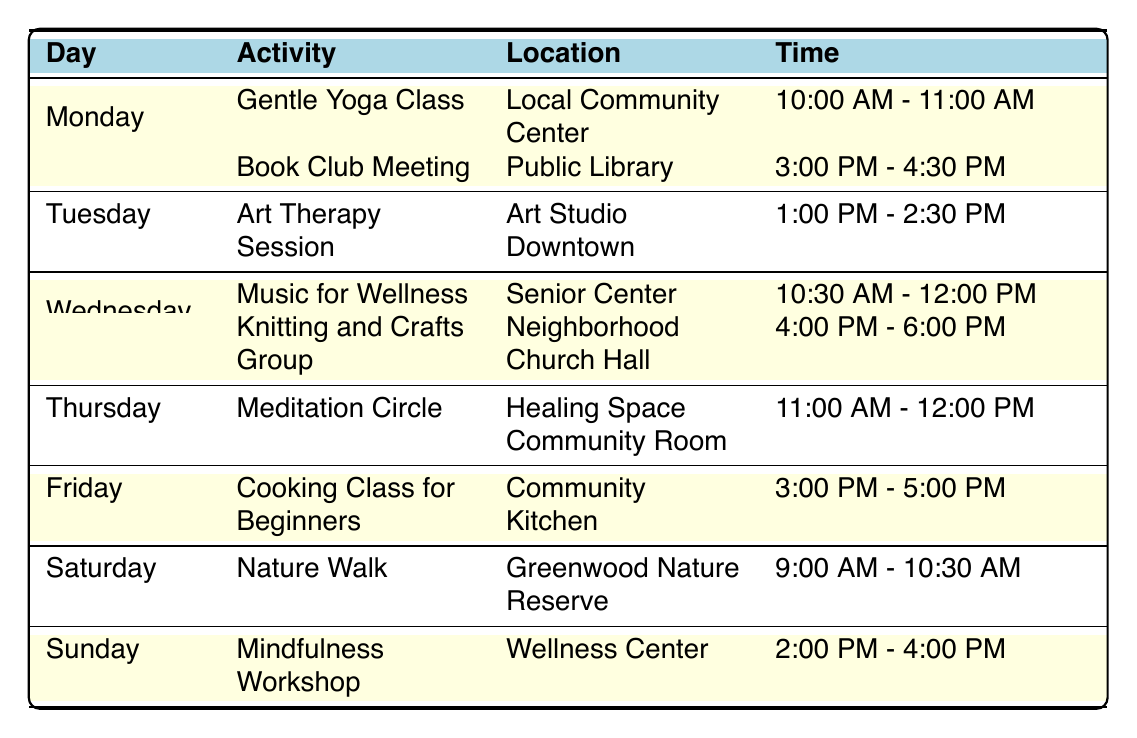What activities are available on Tuesday? Referring to the table, on Tuesday there are two activities listed: "Art Therapy Session" and "Community Gardening."
Answer: Art Therapy Session, Community Gardening What is the location for the Cooking Class for Beginners? The table shows that the Cooking Class for Beginners is held at the Community Kitchen.
Answer: Community Kitchen Is there a Knitting and Crafts Group activity on Wednesday? Yes, the table indicates there is a Knitting and Crafts Group on Wednesday from 4:00 PM to 6:00 PM.
Answer: Yes Which day has an outdoor activity scheduled during the evening? The Outdoor Movie Night is scheduled for Friday at 8:00 PM, which is an outdoor activity.
Answer: Friday What time does the Nature Walk start on Saturday? According to the table, the Nature Walk starts at 9:00 AM on Saturday.
Answer: 9:00 AM How many activities are scheduled on Sunday? The table shows two activities listed for Sunday: "Mindfulness Workshop" and "Local Farmer's Market." Therefore, the total number is two.
Answer: 2 Which activity is offered at the Senior Center, and what time does it take place? The table indicates "Music for Wellness" is offered at the Senior Center from 10:30 AM to 12:00 PM.
Answer: Music for Wellness, 10:30 AM - 12:00 PM On which day is Community Gardening held, and what is its duration? Community Gardening is held on Tuesday, from 5:00 PM to 7:00 PM, which is a duration of 2 hours.
Answer: Tuesday, 2 hours How many activities take place in the evening between Thursday and Saturday? Thursday has Board Games Night from 7:00 PM to 9:00 PM, Friday has Outdoor Movie Night from 8:00 PM to 10:00 PM, and Saturday has no evening activities. Therefore, there are two evening activities.
Answer: 2 What is the location of the Local Farmer's Market, and what are its hours? The table indicates that the Local Farmer's Market takes place at Downtown Square from 9:00 AM to 1:00 PM.
Answer: Downtown Square, 9:00 AM - 1:00 PM Are there any activities that occur concurrently on Monday? Yes, on Monday, the Gentle Yoga Class and Book Club Meeting occur at different times (10:00 AM - 11:00 AM and 3:00 PM - 4:30 PM respectively), indicating they do not overlap. Thus, they are not concurrent.
Answer: No 